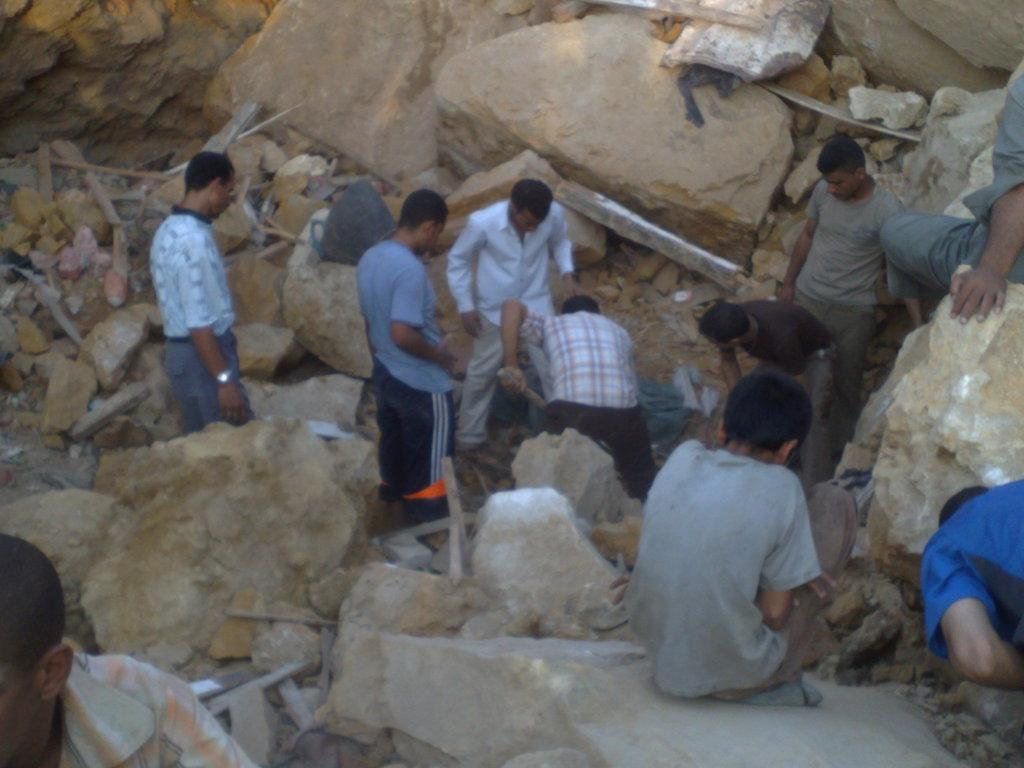How many people are in the group that is visible in the image? There is a group of people standing in the image, but the exact number is not specified. What is in front of the group of people? There are rocks in front of the group. Can you describe the person holding an object in the image? Yes, there is a person holding a stick in the image. What type of acoustics can be heard from the gate in the image? There is no gate present in the image, so it is not possible to determine the acoustics. 